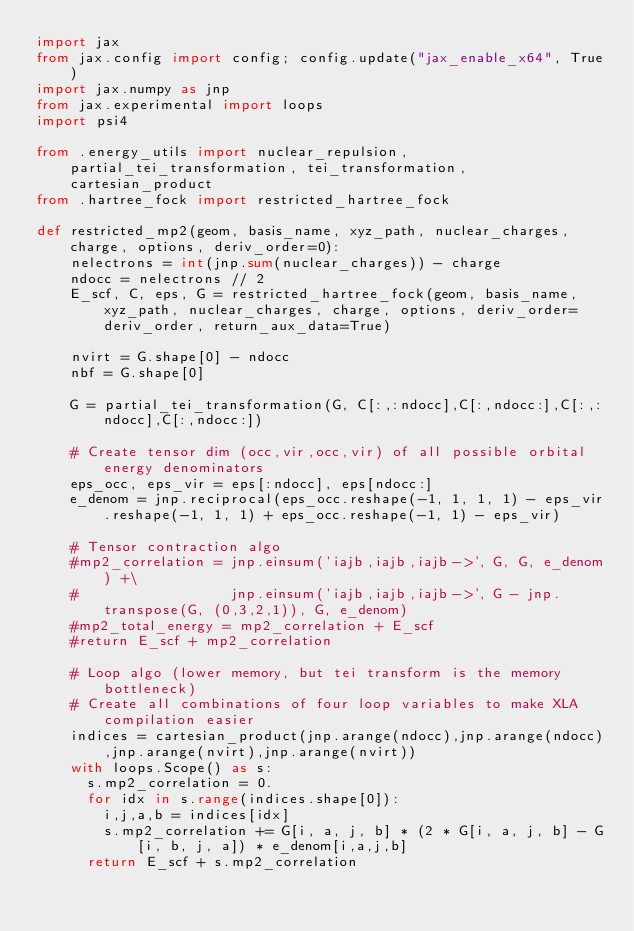Convert code to text. <code><loc_0><loc_0><loc_500><loc_500><_Python_>import jax 
from jax.config import config; config.update("jax_enable_x64", True)
import jax.numpy as jnp
from jax.experimental import loops
import psi4

from .energy_utils import nuclear_repulsion, partial_tei_transformation, tei_transformation, cartesian_product
from .hartree_fock import restricted_hartree_fock

def restricted_mp2(geom, basis_name, xyz_path, nuclear_charges, charge, options, deriv_order=0):
    nelectrons = int(jnp.sum(nuclear_charges)) - charge
    ndocc = nelectrons // 2
    E_scf, C, eps, G = restricted_hartree_fock(geom, basis_name, xyz_path, nuclear_charges, charge, options, deriv_order=deriv_order, return_aux_data=True)

    nvirt = G.shape[0] - ndocc
    nbf = G.shape[0]

    G = partial_tei_transformation(G, C[:,:ndocc],C[:,ndocc:],C[:,:ndocc],C[:,ndocc:])

    # Create tensor dim (occ,vir,occ,vir) of all possible orbital energy denominators
    eps_occ, eps_vir = eps[:ndocc], eps[ndocc:]
    e_denom = jnp.reciprocal(eps_occ.reshape(-1, 1, 1, 1) - eps_vir.reshape(-1, 1, 1) + eps_occ.reshape(-1, 1) - eps_vir)

    # Tensor contraction algo 
    #mp2_correlation = jnp.einsum('iajb,iajb,iajb->', G, G, e_denom) +\
    #                  jnp.einsum('iajb,iajb,iajb->', G - jnp.transpose(G, (0,3,2,1)), G, e_denom)
    #mp2_total_energy = mp2_correlation + E_scf
    #return E_scf + mp2_correlation

    # Loop algo (lower memory, but tei transform is the memory bottleneck)
    # Create all combinations of four loop variables to make XLA compilation easier
    indices = cartesian_product(jnp.arange(ndocc),jnp.arange(ndocc),jnp.arange(nvirt),jnp.arange(nvirt))
    with loops.Scope() as s:
      s.mp2_correlation = 0.
      for idx in s.range(indices.shape[0]):
        i,j,a,b = indices[idx]
        s.mp2_correlation += G[i, a, j, b] * (2 * G[i, a, j, b] - G[i, b, j, a]) * e_denom[i,a,j,b]
      return E_scf + s.mp2_correlation

</code> 